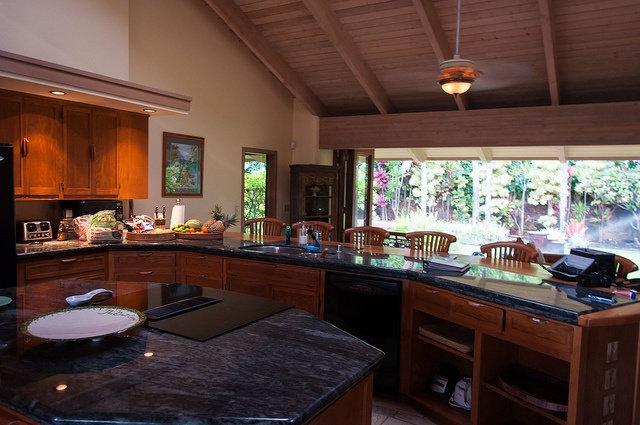Describe the objects in this image and their specific colors. I can see dining table in gray, black, maroon, and darkgray tones, refrigerator in gray, black, and teal tones, potted plant in gray, lightgray, darkgray, lightblue, and teal tones, potted plant in gray, ivory, beige, darkgray, and lightgreen tones, and potted plant in gray, lavender, violet, and darkgray tones in this image. 